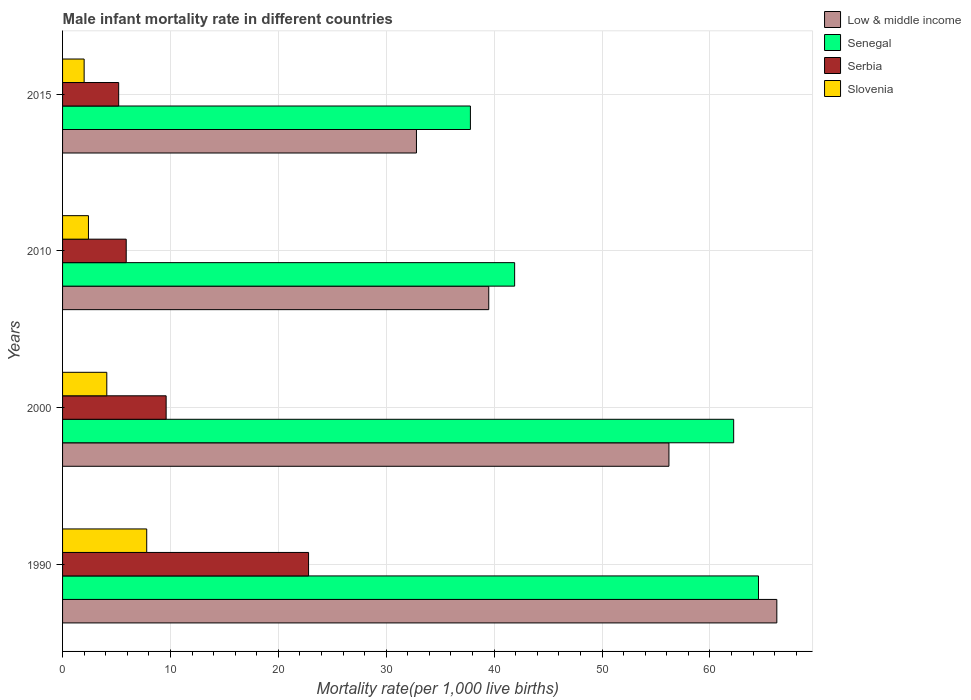How many groups of bars are there?
Offer a terse response. 4. Are the number of bars per tick equal to the number of legend labels?
Provide a succinct answer. Yes. Are the number of bars on each tick of the Y-axis equal?
Keep it short and to the point. Yes. How many bars are there on the 2nd tick from the bottom?
Provide a short and direct response. 4. Across all years, what is the maximum male infant mortality rate in Serbia?
Offer a very short reply. 22.8. Across all years, what is the minimum male infant mortality rate in Low & middle income?
Offer a very short reply. 32.8. In which year was the male infant mortality rate in Low & middle income maximum?
Offer a terse response. 1990. In which year was the male infant mortality rate in Senegal minimum?
Provide a succinct answer. 2015. What is the total male infant mortality rate in Serbia in the graph?
Your answer should be very brief. 43.5. What is the difference between the male infant mortality rate in Serbia in 2000 and that in 2015?
Ensure brevity in your answer.  4.4. What is the average male infant mortality rate in Slovenia per year?
Offer a terse response. 4.07. In the year 2010, what is the difference between the male infant mortality rate in Slovenia and male infant mortality rate in Serbia?
Keep it short and to the point. -3.5. What is the ratio of the male infant mortality rate in Serbia in 2010 to that in 2015?
Make the answer very short. 1.13. Is the male infant mortality rate in Low & middle income in 2000 less than that in 2010?
Your answer should be compact. No. Is the difference between the male infant mortality rate in Slovenia in 2000 and 2010 greater than the difference between the male infant mortality rate in Serbia in 2000 and 2010?
Provide a short and direct response. No. What is the difference between the highest and the second highest male infant mortality rate in Slovenia?
Offer a terse response. 3.7. What is the difference between the highest and the lowest male infant mortality rate in Low & middle income?
Make the answer very short. 33.4. In how many years, is the male infant mortality rate in Senegal greater than the average male infant mortality rate in Senegal taken over all years?
Provide a succinct answer. 2. What does the 3rd bar from the top in 2010 represents?
Your response must be concise. Senegal. What does the 4th bar from the bottom in 2010 represents?
Your response must be concise. Slovenia. Is it the case that in every year, the sum of the male infant mortality rate in Low & middle income and male infant mortality rate in Senegal is greater than the male infant mortality rate in Serbia?
Make the answer very short. Yes. Are the values on the major ticks of X-axis written in scientific E-notation?
Provide a short and direct response. No. Does the graph contain any zero values?
Make the answer very short. No. Where does the legend appear in the graph?
Provide a succinct answer. Top right. What is the title of the graph?
Make the answer very short. Male infant mortality rate in different countries. Does "High income: nonOECD" appear as one of the legend labels in the graph?
Your answer should be compact. No. What is the label or title of the X-axis?
Make the answer very short. Mortality rate(per 1,0 live births). What is the label or title of the Y-axis?
Keep it short and to the point. Years. What is the Mortality rate(per 1,000 live births) of Low & middle income in 1990?
Provide a short and direct response. 66.2. What is the Mortality rate(per 1,000 live births) of Senegal in 1990?
Ensure brevity in your answer.  64.5. What is the Mortality rate(per 1,000 live births) of Serbia in 1990?
Give a very brief answer. 22.8. What is the Mortality rate(per 1,000 live births) in Slovenia in 1990?
Offer a very short reply. 7.8. What is the Mortality rate(per 1,000 live births) in Low & middle income in 2000?
Give a very brief answer. 56.2. What is the Mortality rate(per 1,000 live births) in Senegal in 2000?
Your answer should be compact. 62.2. What is the Mortality rate(per 1,000 live births) in Slovenia in 2000?
Your response must be concise. 4.1. What is the Mortality rate(per 1,000 live births) in Low & middle income in 2010?
Make the answer very short. 39.5. What is the Mortality rate(per 1,000 live births) in Senegal in 2010?
Provide a short and direct response. 41.9. What is the Mortality rate(per 1,000 live births) in Serbia in 2010?
Make the answer very short. 5.9. What is the Mortality rate(per 1,000 live births) in Slovenia in 2010?
Provide a succinct answer. 2.4. What is the Mortality rate(per 1,000 live births) of Low & middle income in 2015?
Offer a very short reply. 32.8. What is the Mortality rate(per 1,000 live births) of Senegal in 2015?
Make the answer very short. 37.8. What is the Mortality rate(per 1,000 live births) in Serbia in 2015?
Offer a terse response. 5.2. Across all years, what is the maximum Mortality rate(per 1,000 live births) in Low & middle income?
Ensure brevity in your answer.  66.2. Across all years, what is the maximum Mortality rate(per 1,000 live births) in Senegal?
Offer a very short reply. 64.5. Across all years, what is the maximum Mortality rate(per 1,000 live births) in Serbia?
Provide a short and direct response. 22.8. Across all years, what is the maximum Mortality rate(per 1,000 live births) in Slovenia?
Your answer should be compact. 7.8. Across all years, what is the minimum Mortality rate(per 1,000 live births) of Low & middle income?
Your response must be concise. 32.8. Across all years, what is the minimum Mortality rate(per 1,000 live births) in Senegal?
Make the answer very short. 37.8. Across all years, what is the minimum Mortality rate(per 1,000 live births) in Slovenia?
Give a very brief answer. 2. What is the total Mortality rate(per 1,000 live births) in Low & middle income in the graph?
Keep it short and to the point. 194.7. What is the total Mortality rate(per 1,000 live births) in Senegal in the graph?
Offer a terse response. 206.4. What is the total Mortality rate(per 1,000 live births) in Serbia in the graph?
Provide a short and direct response. 43.5. What is the difference between the Mortality rate(per 1,000 live births) of Senegal in 1990 and that in 2000?
Your response must be concise. 2.3. What is the difference between the Mortality rate(per 1,000 live births) of Low & middle income in 1990 and that in 2010?
Make the answer very short. 26.7. What is the difference between the Mortality rate(per 1,000 live births) of Senegal in 1990 and that in 2010?
Your answer should be compact. 22.6. What is the difference between the Mortality rate(per 1,000 live births) in Low & middle income in 1990 and that in 2015?
Offer a terse response. 33.4. What is the difference between the Mortality rate(per 1,000 live births) in Senegal in 1990 and that in 2015?
Offer a very short reply. 26.7. What is the difference between the Mortality rate(per 1,000 live births) in Senegal in 2000 and that in 2010?
Offer a very short reply. 20.3. What is the difference between the Mortality rate(per 1,000 live births) in Slovenia in 2000 and that in 2010?
Provide a succinct answer. 1.7. What is the difference between the Mortality rate(per 1,000 live births) in Low & middle income in 2000 and that in 2015?
Your answer should be very brief. 23.4. What is the difference between the Mortality rate(per 1,000 live births) in Senegal in 2000 and that in 2015?
Your answer should be very brief. 24.4. What is the difference between the Mortality rate(per 1,000 live births) in Serbia in 2000 and that in 2015?
Your response must be concise. 4.4. What is the difference between the Mortality rate(per 1,000 live births) of Slovenia in 2000 and that in 2015?
Ensure brevity in your answer.  2.1. What is the difference between the Mortality rate(per 1,000 live births) of Low & middle income in 2010 and that in 2015?
Provide a short and direct response. 6.7. What is the difference between the Mortality rate(per 1,000 live births) of Senegal in 2010 and that in 2015?
Provide a succinct answer. 4.1. What is the difference between the Mortality rate(per 1,000 live births) in Low & middle income in 1990 and the Mortality rate(per 1,000 live births) in Serbia in 2000?
Provide a succinct answer. 56.6. What is the difference between the Mortality rate(per 1,000 live births) of Low & middle income in 1990 and the Mortality rate(per 1,000 live births) of Slovenia in 2000?
Offer a very short reply. 62.1. What is the difference between the Mortality rate(per 1,000 live births) in Senegal in 1990 and the Mortality rate(per 1,000 live births) in Serbia in 2000?
Offer a terse response. 54.9. What is the difference between the Mortality rate(per 1,000 live births) in Senegal in 1990 and the Mortality rate(per 1,000 live births) in Slovenia in 2000?
Provide a succinct answer. 60.4. What is the difference between the Mortality rate(per 1,000 live births) of Serbia in 1990 and the Mortality rate(per 1,000 live births) of Slovenia in 2000?
Your answer should be very brief. 18.7. What is the difference between the Mortality rate(per 1,000 live births) of Low & middle income in 1990 and the Mortality rate(per 1,000 live births) of Senegal in 2010?
Your response must be concise. 24.3. What is the difference between the Mortality rate(per 1,000 live births) of Low & middle income in 1990 and the Mortality rate(per 1,000 live births) of Serbia in 2010?
Provide a short and direct response. 60.3. What is the difference between the Mortality rate(per 1,000 live births) of Low & middle income in 1990 and the Mortality rate(per 1,000 live births) of Slovenia in 2010?
Provide a short and direct response. 63.8. What is the difference between the Mortality rate(per 1,000 live births) in Senegal in 1990 and the Mortality rate(per 1,000 live births) in Serbia in 2010?
Give a very brief answer. 58.6. What is the difference between the Mortality rate(per 1,000 live births) of Senegal in 1990 and the Mortality rate(per 1,000 live births) of Slovenia in 2010?
Your response must be concise. 62.1. What is the difference between the Mortality rate(per 1,000 live births) of Serbia in 1990 and the Mortality rate(per 1,000 live births) of Slovenia in 2010?
Give a very brief answer. 20.4. What is the difference between the Mortality rate(per 1,000 live births) in Low & middle income in 1990 and the Mortality rate(per 1,000 live births) in Senegal in 2015?
Offer a very short reply. 28.4. What is the difference between the Mortality rate(per 1,000 live births) in Low & middle income in 1990 and the Mortality rate(per 1,000 live births) in Slovenia in 2015?
Provide a succinct answer. 64.2. What is the difference between the Mortality rate(per 1,000 live births) of Senegal in 1990 and the Mortality rate(per 1,000 live births) of Serbia in 2015?
Give a very brief answer. 59.3. What is the difference between the Mortality rate(per 1,000 live births) of Senegal in 1990 and the Mortality rate(per 1,000 live births) of Slovenia in 2015?
Ensure brevity in your answer.  62.5. What is the difference between the Mortality rate(per 1,000 live births) of Serbia in 1990 and the Mortality rate(per 1,000 live births) of Slovenia in 2015?
Provide a succinct answer. 20.8. What is the difference between the Mortality rate(per 1,000 live births) of Low & middle income in 2000 and the Mortality rate(per 1,000 live births) of Senegal in 2010?
Provide a succinct answer. 14.3. What is the difference between the Mortality rate(per 1,000 live births) of Low & middle income in 2000 and the Mortality rate(per 1,000 live births) of Serbia in 2010?
Your response must be concise. 50.3. What is the difference between the Mortality rate(per 1,000 live births) in Low & middle income in 2000 and the Mortality rate(per 1,000 live births) in Slovenia in 2010?
Ensure brevity in your answer.  53.8. What is the difference between the Mortality rate(per 1,000 live births) in Senegal in 2000 and the Mortality rate(per 1,000 live births) in Serbia in 2010?
Make the answer very short. 56.3. What is the difference between the Mortality rate(per 1,000 live births) in Senegal in 2000 and the Mortality rate(per 1,000 live births) in Slovenia in 2010?
Give a very brief answer. 59.8. What is the difference between the Mortality rate(per 1,000 live births) in Serbia in 2000 and the Mortality rate(per 1,000 live births) in Slovenia in 2010?
Offer a terse response. 7.2. What is the difference between the Mortality rate(per 1,000 live births) of Low & middle income in 2000 and the Mortality rate(per 1,000 live births) of Senegal in 2015?
Make the answer very short. 18.4. What is the difference between the Mortality rate(per 1,000 live births) in Low & middle income in 2000 and the Mortality rate(per 1,000 live births) in Slovenia in 2015?
Provide a succinct answer. 54.2. What is the difference between the Mortality rate(per 1,000 live births) in Senegal in 2000 and the Mortality rate(per 1,000 live births) in Slovenia in 2015?
Your answer should be very brief. 60.2. What is the difference between the Mortality rate(per 1,000 live births) in Low & middle income in 2010 and the Mortality rate(per 1,000 live births) in Serbia in 2015?
Provide a succinct answer. 34.3. What is the difference between the Mortality rate(per 1,000 live births) of Low & middle income in 2010 and the Mortality rate(per 1,000 live births) of Slovenia in 2015?
Keep it short and to the point. 37.5. What is the difference between the Mortality rate(per 1,000 live births) of Senegal in 2010 and the Mortality rate(per 1,000 live births) of Serbia in 2015?
Provide a short and direct response. 36.7. What is the difference between the Mortality rate(per 1,000 live births) in Senegal in 2010 and the Mortality rate(per 1,000 live births) in Slovenia in 2015?
Offer a terse response. 39.9. What is the difference between the Mortality rate(per 1,000 live births) in Serbia in 2010 and the Mortality rate(per 1,000 live births) in Slovenia in 2015?
Your answer should be compact. 3.9. What is the average Mortality rate(per 1,000 live births) of Low & middle income per year?
Make the answer very short. 48.67. What is the average Mortality rate(per 1,000 live births) of Senegal per year?
Your answer should be compact. 51.6. What is the average Mortality rate(per 1,000 live births) of Serbia per year?
Your answer should be very brief. 10.88. What is the average Mortality rate(per 1,000 live births) in Slovenia per year?
Your answer should be compact. 4.08. In the year 1990, what is the difference between the Mortality rate(per 1,000 live births) of Low & middle income and Mortality rate(per 1,000 live births) of Serbia?
Your response must be concise. 43.4. In the year 1990, what is the difference between the Mortality rate(per 1,000 live births) of Low & middle income and Mortality rate(per 1,000 live births) of Slovenia?
Your response must be concise. 58.4. In the year 1990, what is the difference between the Mortality rate(per 1,000 live births) of Senegal and Mortality rate(per 1,000 live births) of Serbia?
Your answer should be very brief. 41.7. In the year 1990, what is the difference between the Mortality rate(per 1,000 live births) in Senegal and Mortality rate(per 1,000 live births) in Slovenia?
Offer a terse response. 56.7. In the year 1990, what is the difference between the Mortality rate(per 1,000 live births) of Serbia and Mortality rate(per 1,000 live births) of Slovenia?
Offer a very short reply. 15. In the year 2000, what is the difference between the Mortality rate(per 1,000 live births) in Low & middle income and Mortality rate(per 1,000 live births) in Serbia?
Your response must be concise. 46.6. In the year 2000, what is the difference between the Mortality rate(per 1,000 live births) in Low & middle income and Mortality rate(per 1,000 live births) in Slovenia?
Provide a short and direct response. 52.1. In the year 2000, what is the difference between the Mortality rate(per 1,000 live births) of Senegal and Mortality rate(per 1,000 live births) of Serbia?
Your answer should be very brief. 52.6. In the year 2000, what is the difference between the Mortality rate(per 1,000 live births) of Senegal and Mortality rate(per 1,000 live births) of Slovenia?
Your answer should be compact. 58.1. In the year 2000, what is the difference between the Mortality rate(per 1,000 live births) of Serbia and Mortality rate(per 1,000 live births) of Slovenia?
Offer a very short reply. 5.5. In the year 2010, what is the difference between the Mortality rate(per 1,000 live births) of Low & middle income and Mortality rate(per 1,000 live births) of Senegal?
Provide a succinct answer. -2.4. In the year 2010, what is the difference between the Mortality rate(per 1,000 live births) in Low & middle income and Mortality rate(per 1,000 live births) in Serbia?
Provide a succinct answer. 33.6. In the year 2010, what is the difference between the Mortality rate(per 1,000 live births) of Low & middle income and Mortality rate(per 1,000 live births) of Slovenia?
Offer a terse response. 37.1. In the year 2010, what is the difference between the Mortality rate(per 1,000 live births) in Senegal and Mortality rate(per 1,000 live births) in Serbia?
Offer a terse response. 36. In the year 2010, what is the difference between the Mortality rate(per 1,000 live births) of Senegal and Mortality rate(per 1,000 live births) of Slovenia?
Provide a succinct answer. 39.5. In the year 2015, what is the difference between the Mortality rate(per 1,000 live births) of Low & middle income and Mortality rate(per 1,000 live births) of Senegal?
Give a very brief answer. -5. In the year 2015, what is the difference between the Mortality rate(per 1,000 live births) in Low & middle income and Mortality rate(per 1,000 live births) in Serbia?
Your response must be concise. 27.6. In the year 2015, what is the difference between the Mortality rate(per 1,000 live births) in Low & middle income and Mortality rate(per 1,000 live births) in Slovenia?
Provide a short and direct response. 30.8. In the year 2015, what is the difference between the Mortality rate(per 1,000 live births) of Senegal and Mortality rate(per 1,000 live births) of Serbia?
Give a very brief answer. 32.6. In the year 2015, what is the difference between the Mortality rate(per 1,000 live births) of Senegal and Mortality rate(per 1,000 live births) of Slovenia?
Your answer should be very brief. 35.8. In the year 2015, what is the difference between the Mortality rate(per 1,000 live births) of Serbia and Mortality rate(per 1,000 live births) of Slovenia?
Offer a very short reply. 3.2. What is the ratio of the Mortality rate(per 1,000 live births) of Low & middle income in 1990 to that in 2000?
Your answer should be very brief. 1.18. What is the ratio of the Mortality rate(per 1,000 live births) of Serbia in 1990 to that in 2000?
Your answer should be compact. 2.38. What is the ratio of the Mortality rate(per 1,000 live births) in Slovenia in 1990 to that in 2000?
Your answer should be very brief. 1.9. What is the ratio of the Mortality rate(per 1,000 live births) of Low & middle income in 1990 to that in 2010?
Offer a terse response. 1.68. What is the ratio of the Mortality rate(per 1,000 live births) of Senegal in 1990 to that in 2010?
Ensure brevity in your answer.  1.54. What is the ratio of the Mortality rate(per 1,000 live births) of Serbia in 1990 to that in 2010?
Ensure brevity in your answer.  3.86. What is the ratio of the Mortality rate(per 1,000 live births) of Slovenia in 1990 to that in 2010?
Ensure brevity in your answer.  3.25. What is the ratio of the Mortality rate(per 1,000 live births) in Low & middle income in 1990 to that in 2015?
Ensure brevity in your answer.  2.02. What is the ratio of the Mortality rate(per 1,000 live births) in Senegal in 1990 to that in 2015?
Ensure brevity in your answer.  1.71. What is the ratio of the Mortality rate(per 1,000 live births) of Serbia in 1990 to that in 2015?
Your answer should be very brief. 4.38. What is the ratio of the Mortality rate(per 1,000 live births) in Slovenia in 1990 to that in 2015?
Provide a short and direct response. 3.9. What is the ratio of the Mortality rate(per 1,000 live births) in Low & middle income in 2000 to that in 2010?
Your answer should be compact. 1.42. What is the ratio of the Mortality rate(per 1,000 live births) in Senegal in 2000 to that in 2010?
Your answer should be very brief. 1.48. What is the ratio of the Mortality rate(per 1,000 live births) of Serbia in 2000 to that in 2010?
Ensure brevity in your answer.  1.63. What is the ratio of the Mortality rate(per 1,000 live births) in Slovenia in 2000 to that in 2010?
Provide a short and direct response. 1.71. What is the ratio of the Mortality rate(per 1,000 live births) in Low & middle income in 2000 to that in 2015?
Provide a succinct answer. 1.71. What is the ratio of the Mortality rate(per 1,000 live births) in Senegal in 2000 to that in 2015?
Make the answer very short. 1.65. What is the ratio of the Mortality rate(per 1,000 live births) in Serbia in 2000 to that in 2015?
Keep it short and to the point. 1.85. What is the ratio of the Mortality rate(per 1,000 live births) in Slovenia in 2000 to that in 2015?
Your answer should be compact. 2.05. What is the ratio of the Mortality rate(per 1,000 live births) in Low & middle income in 2010 to that in 2015?
Ensure brevity in your answer.  1.2. What is the ratio of the Mortality rate(per 1,000 live births) in Senegal in 2010 to that in 2015?
Provide a short and direct response. 1.11. What is the ratio of the Mortality rate(per 1,000 live births) of Serbia in 2010 to that in 2015?
Your answer should be compact. 1.13. What is the ratio of the Mortality rate(per 1,000 live births) of Slovenia in 2010 to that in 2015?
Give a very brief answer. 1.2. What is the difference between the highest and the second highest Mortality rate(per 1,000 live births) of Low & middle income?
Your answer should be compact. 10. What is the difference between the highest and the second highest Mortality rate(per 1,000 live births) of Senegal?
Ensure brevity in your answer.  2.3. What is the difference between the highest and the second highest Mortality rate(per 1,000 live births) of Slovenia?
Provide a succinct answer. 3.7. What is the difference between the highest and the lowest Mortality rate(per 1,000 live births) of Low & middle income?
Your answer should be compact. 33.4. What is the difference between the highest and the lowest Mortality rate(per 1,000 live births) in Senegal?
Give a very brief answer. 26.7. 